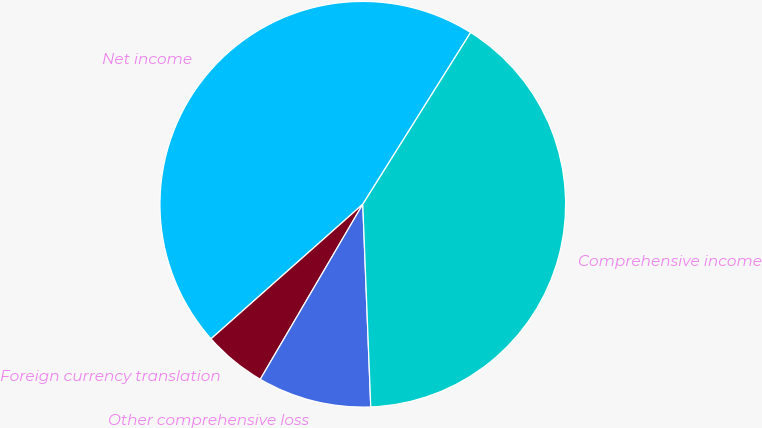<chart> <loc_0><loc_0><loc_500><loc_500><pie_chart><fcel>Net income<fcel>Foreign currency translation<fcel>Other comprehensive loss<fcel>Comprehensive income<nl><fcel>45.47%<fcel>5.02%<fcel>9.06%<fcel>40.45%<nl></chart> 